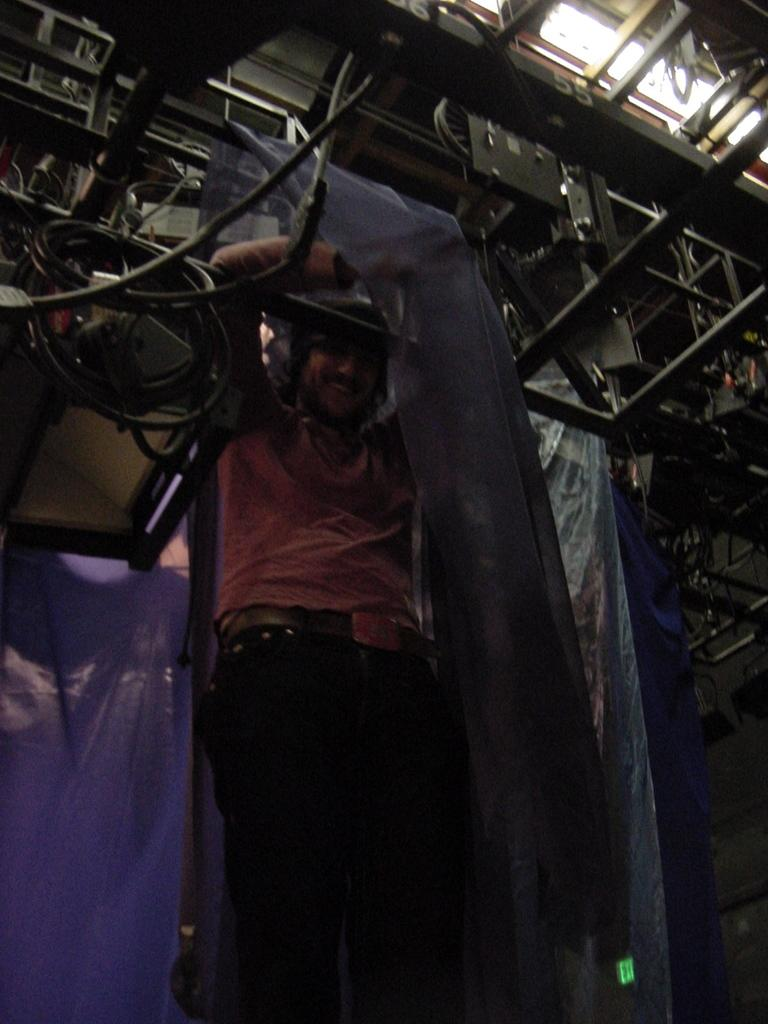What is the person in the image doing? The person is standing in the image. What expression does the person have? The person is smiling. What can be seen at the top of the image? There are metal rods at the top of the image. What is visible in the background of the image? There are covers visible in the background of the image. What type of stocking is the person wearing in the image? There is no mention of stockings in the image, so it cannot be determined if the person is wearing any. 